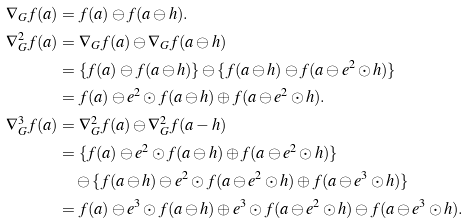Convert formula to latex. <formula><loc_0><loc_0><loc_500><loc_500>\nabla _ { G } f ( a ) & = f ( a ) \ominus f ( a \ominus h ) . \\ \nabla ^ { 2 } _ { G } f ( a ) & = \nabla _ { G } f ( a ) \ominus \nabla _ { G } f ( a \ominus h ) \\ & = \{ f ( a ) \ominus f ( a \ominus h ) \} \ominus \{ f ( a \ominus h ) \ominus f ( a \ominus e ^ { 2 } \odot h ) \} \\ & = f ( a ) \ominus e ^ { 2 } \odot f ( a \ominus h ) \oplus f ( a \ominus e ^ { 2 } \odot h ) . \\ \nabla ^ { 3 } _ { G } f ( a ) & = \nabla ^ { 2 } _ { G } f ( a ) \ominus \nabla ^ { 2 } _ { G } f ( a - h ) \\ & = \{ f ( a ) \ominus e ^ { 2 } \odot f ( a \ominus h ) \oplus f ( a \ominus e ^ { 2 } \odot h ) \} \\ & \quad \ominus \{ f ( a \ominus h ) \ominus e ^ { 2 } \odot f ( a \ominus e ^ { 2 } \odot h ) \oplus f ( a \ominus e ^ { 3 } \odot h ) \} \\ & = f ( a ) \ominus e ^ { 3 } \odot f ( a \ominus h ) \oplus e ^ { 3 } \odot f ( a \ominus e ^ { 2 } \odot h ) \ominus f ( a \ominus e ^ { 3 } \odot h ) .</formula> 